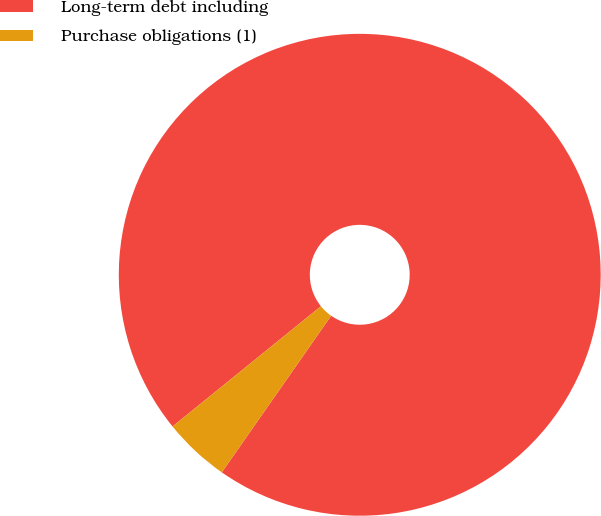Convert chart. <chart><loc_0><loc_0><loc_500><loc_500><pie_chart><fcel>Long-term debt including<fcel>Purchase obligations (1)<nl><fcel>95.54%<fcel>4.46%<nl></chart> 